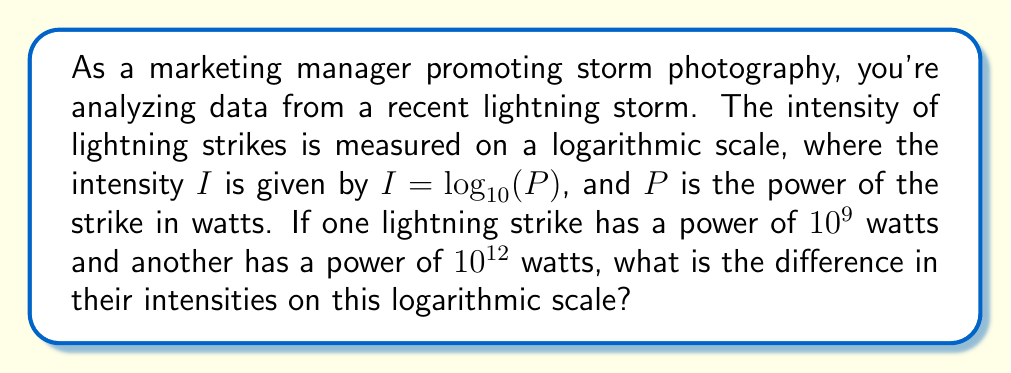Can you answer this question? Let's approach this step-by-step:

1) We're given that $I = \log_{10}(P)$ where $I$ is the intensity and $P$ is the power in watts.

2) For the first lightning strike:
   $P_1 = 10^9$ watts
   $I_1 = \log_{10}(10^9) = 9$

3) For the second lightning strike:
   $P_2 = 10^{12}$ watts
   $I_2 = \log_{10}(10^{12}) = 12$

4) The difference in intensity is:
   $\Delta I = I_2 - I_1 = 12 - 9 = 3$

This means that on the logarithmic scale, the second lightning strike is 3 units more intense than the first.
Answer: 3 